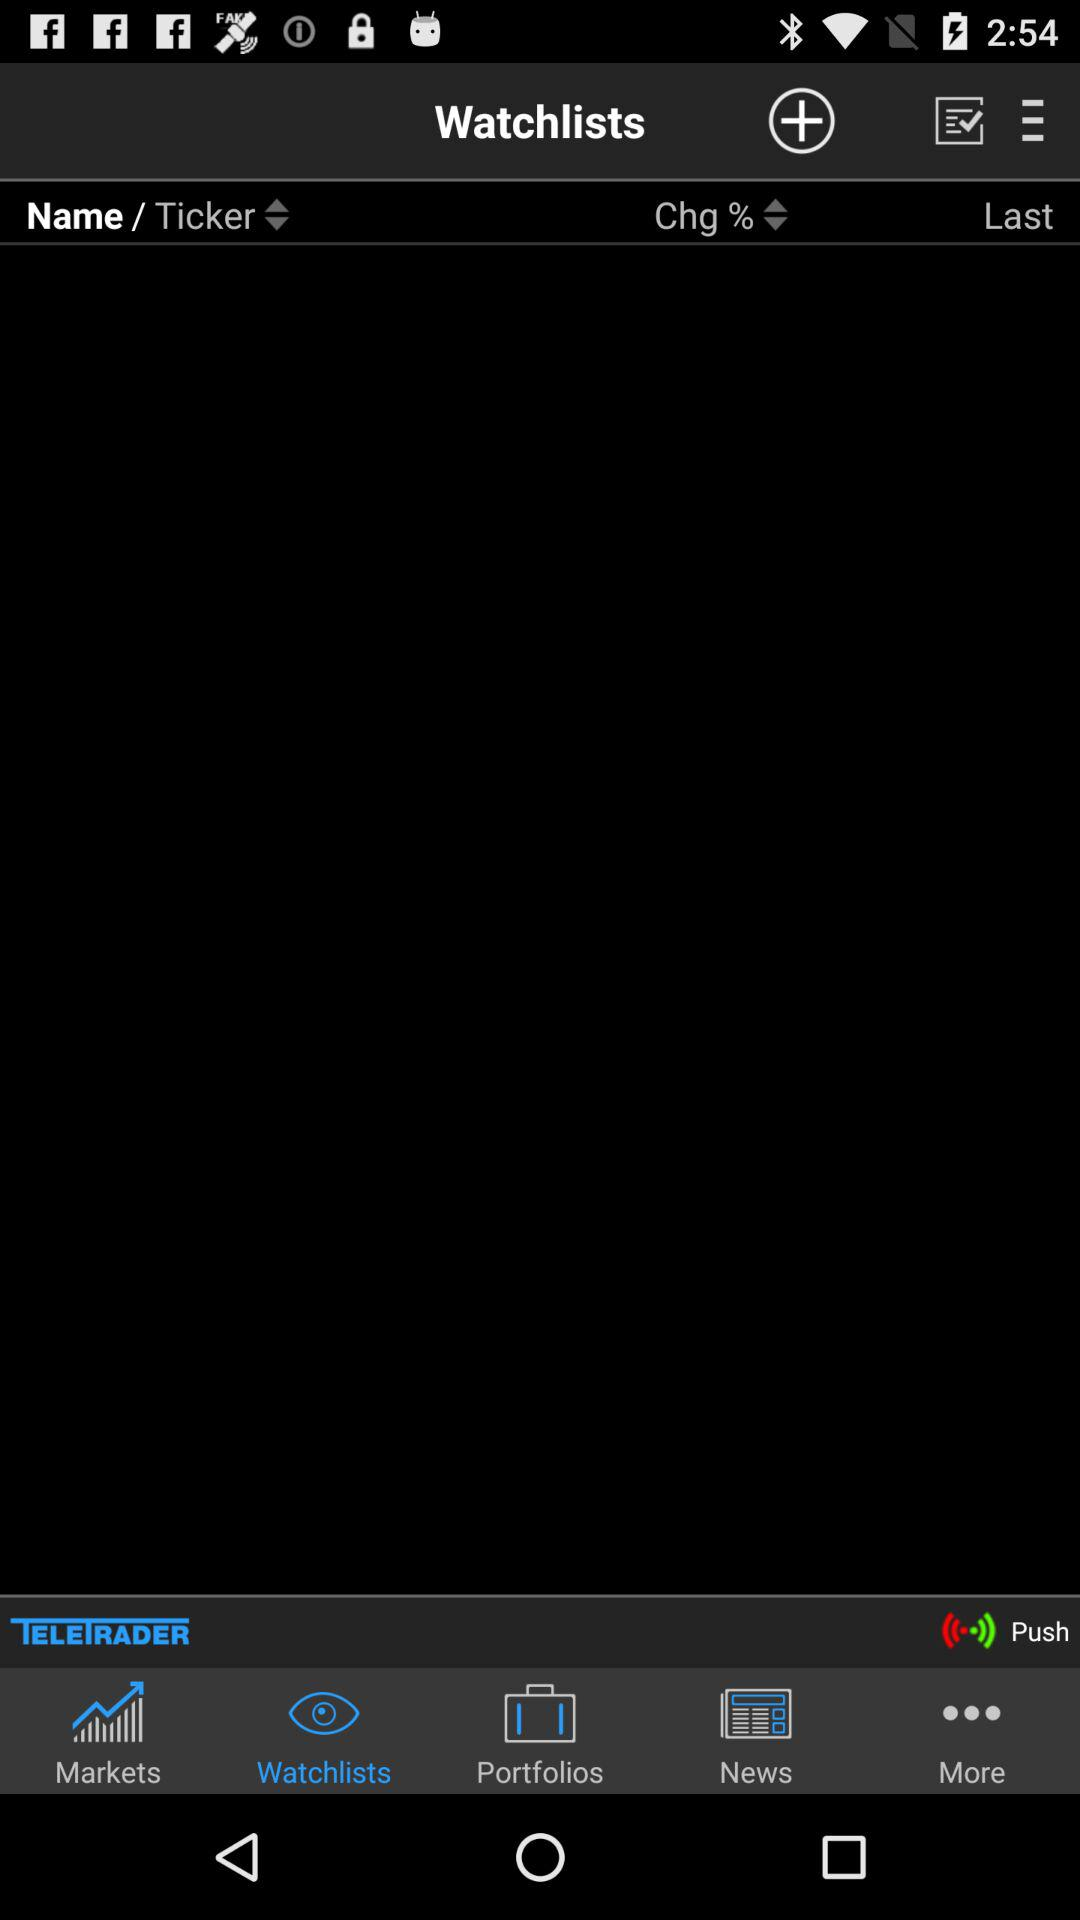Which tab am I on? You are on the "Watchlists" tab. 